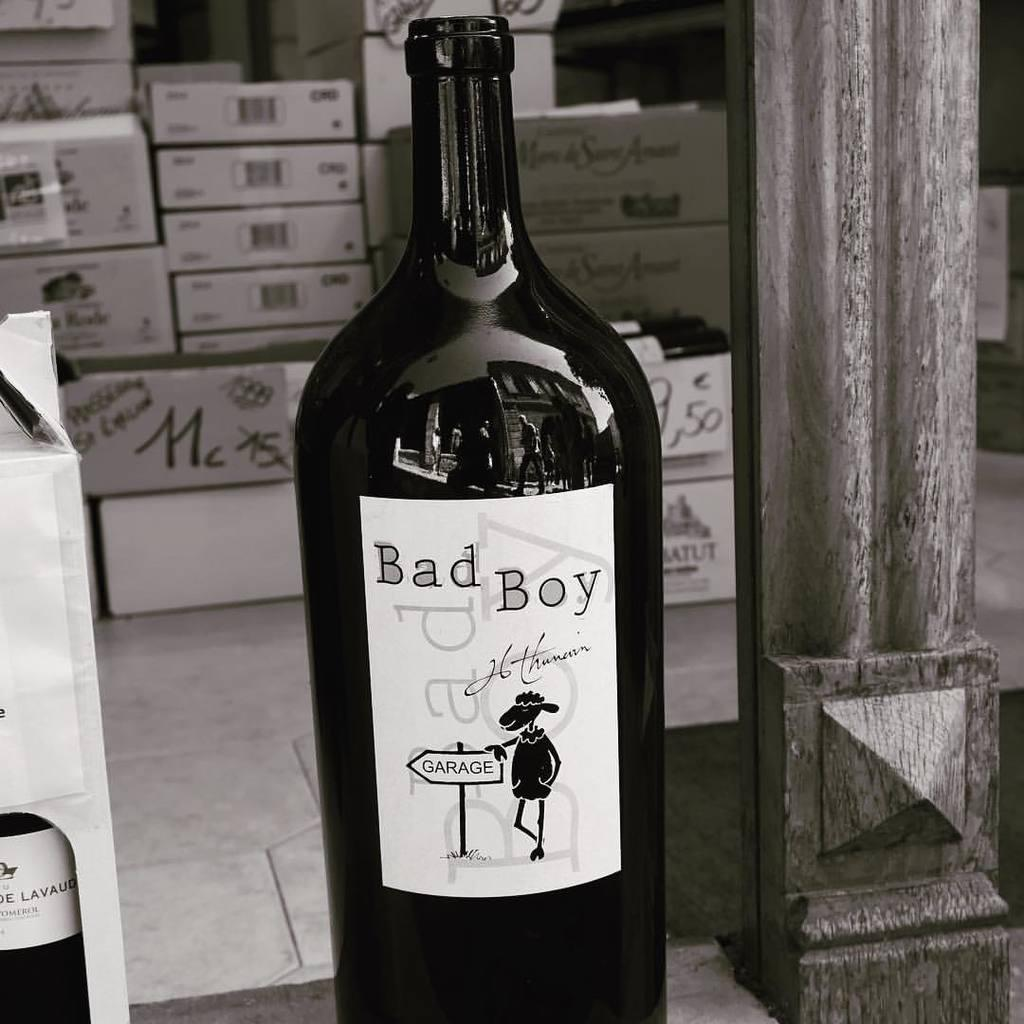<image>
Create a compact narrative representing the image presented. A large dark colored glass bottle with a black sheep on the label and the text "Bad Boy" 